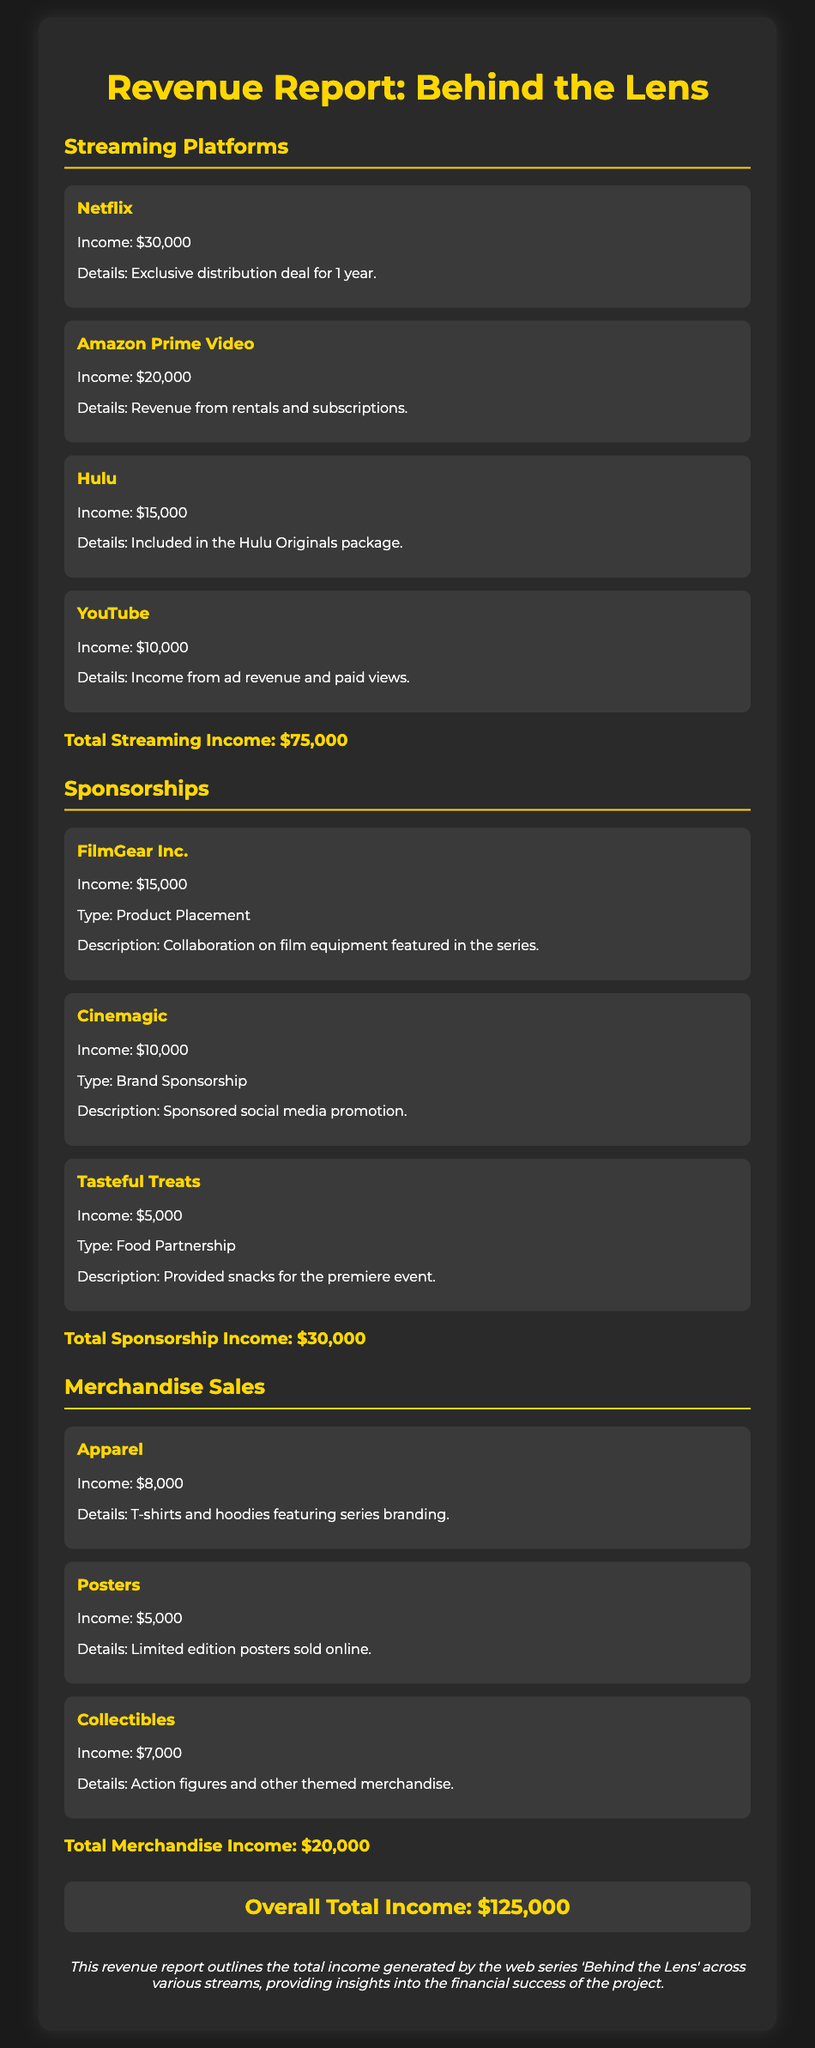What is the total income from streaming platforms? The total income from streaming platforms is explicitly stated in the document as $75,000.
Answer: $75,000 Who is the sponsor that provided $15,000? The document lists FilmGear Inc. as the sponsor contributing $15,000.
Answer: FilmGear Inc What is the income from merchandise sales? The total income from merchandise sales is provided in the report as $20,000.
Answer: $20,000 How much did Hulu contribute? The income contributed by Hulu is specified in the document as $15,000.
Answer: $15,000 What is the overall total income reported? The report states the overall total income as $125,000, aggregating all revenue sources.
Answer: $125,000 How many sponsors provided income in total? The document outlines three sponsors that contributed to the revenue, requiring a count of the sponsorship entries.
Answer: Three What type of sponsorship did Tasteful Treats provide? The document describes Tasteful Treats' sponsorship as a Food Partnership.
Answer: Food Partnership What was the income from apparel merchandise? The report indicates the income from apparel as $8,000.
Answer: $8,000 Which streaming platform generated the highest income? According to the document, Netflix generated the highest income with $30,000.
Answer: Netflix 